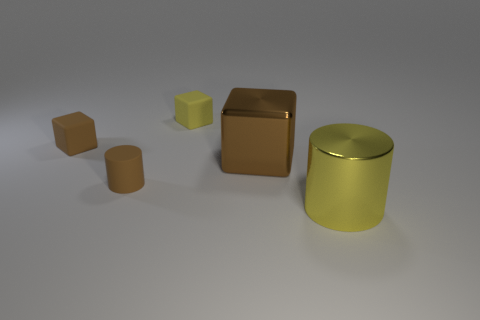Subtract all small brown cubes. How many cubes are left? 2 Subtract all yellow cubes. How many cubes are left? 2 Subtract 2 blocks. How many blocks are left? 1 Subtract all cylinders. How many objects are left? 3 Add 5 large brown metal objects. How many objects exist? 10 Subtract 0 cyan blocks. How many objects are left? 5 Subtract all gray cubes. Subtract all yellow balls. How many cubes are left? 3 Subtract all brown cylinders. How many yellow blocks are left? 1 Subtract all red rubber cubes. Subtract all matte blocks. How many objects are left? 3 Add 4 things. How many things are left? 9 